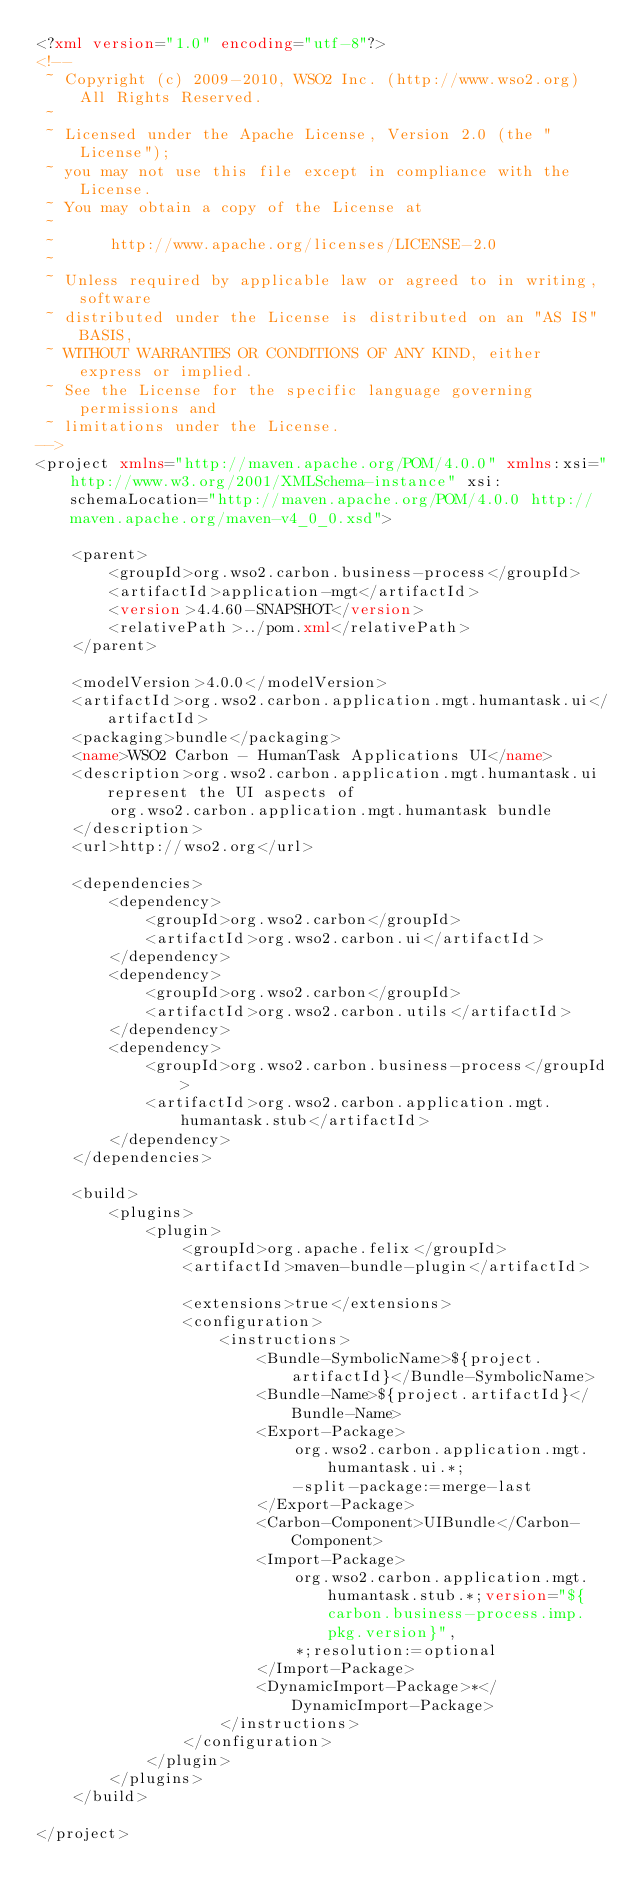<code> <loc_0><loc_0><loc_500><loc_500><_XML_><?xml version="1.0" encoding="utf-8"?>
<!--
 ~ Copyright (c) 2009-2010, WSO2 Inc. (http://www.wso2.org) All Rights Reserved.
 ~
 ~ Licensed under the Apache License, Version 2.0 (the "License");
 ~ you may not use this file except in compliance with the License.
 ~ You may obtain a copy of the License at
 ~
 ~      http://www.apache.org/licenses/LICENSE-2.0
 ~
 ~ Unless required by applicable law or agreed to in writing, software
 ~ distributed under the License is distributed on an "AS IS" BASIS,
 ~ WITHOUT WARRANTIES OR CONDITIONS OF ANY KIND, either express or implied.
 ~ See the License for the specific language governing permissions and
 ~ limitations under the License.
-->
<project xmlns="http://maven.apache.org/POM/4.0.0" xmlns:xsi="http://www.w3.org/2001/XMLSchema-instance" xsi:schemaLocation="http://maven.apache.org/POM/4.0.0 http://maven.apache.org/maven-v4_0_0.xsd">

    <parent>
        <groupId>org.wso2.carbon.business-process</groupId>
        <artifactId>application-mgt</artifactId>
        <version>4.4.60-SNAPSHOT</version>
        <relativePath>../pom.xml</relativePath>
    </parent>

    <modelVersion>4.0.0</modelVersion>
    <artifactId>org.wso2.carbon.application.mgt.humantask.ui</artifactId>
    <packaging>bundle</packaging>
    <name>WSO2 Carbon - HumanTask Applications UI</name>
    <description>org.wso2.carbon.application.mgt.humantask.ui represent the UI aspects of
        org.wso2.carbon.application.mgt.humantask bundle
    </description>
    <url>http://wso2.org</url>

    <dependencies>
        <dependency>
            <groupId>org.wso2.carbon</groupId>
            <artifactId>org.wso2.carbon.ui</artifactId>
        </dependency>
        <dependency>
            <groupId>org.wso2.carbon</groupId>
            <artifactId>org.wso2.carbon.utils</artifactId>
        </dependency>
        <dependency>
            <groupId>org.wso2.carbon.business-process</groupId>
            <artifactId>org.wso2.carbon.application.mgt.humantask.stub</artifactId>
        </dependency>
    </dependencies>

    <build>
        <plugins>
            <plugin>
                <groupId>org.apache.felix</groupId>
                <artifactId>maven-bundle-plugin</artifactId>

                <extensions>true</extensions>
                <configuration>
                    <instructions>
                        <Bundle-SymbolicName>${project.artifactId}</Bundle-SymbolicName>
                        <Bundle-Name>${project.artifactId}</Bundle-Name>
                        <Export-Package>
                            org.wso2.carbon.application.mgt.humantask.ui.*;
                            -split-package:=merge-last
                        </Export-Package>
                        <Carbon-Component>UIBundle</Carbon-Component>
                        <Import-Package>
                            org.wso2.carbon.application.mgt.humantask.stub.*;version="${carbon.business-process.imp.pkg.version}",
                            *;resolution:=optional
                        </Import-Package>
                        <DynamicImport-Package>*</DynamicImport-Package>
                    </instructions>
                </configuration>
            </plugin>
        </plugins>
    </build>

</project>
</code> 